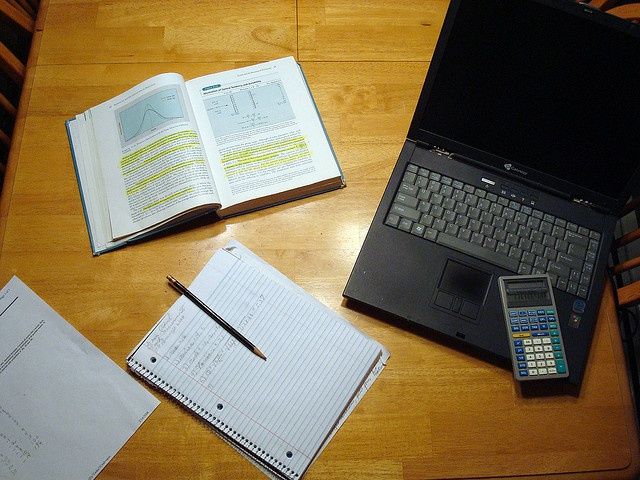Describe the objects in this image and their specific colors. I can see laptop in maroon, black, and gray tones, book in maroon, lightgray, lightblue, darkgray, and khaki tones, book in maroon, lightgray, and darkgray tones, and chair in maroon and black tones in this image. 